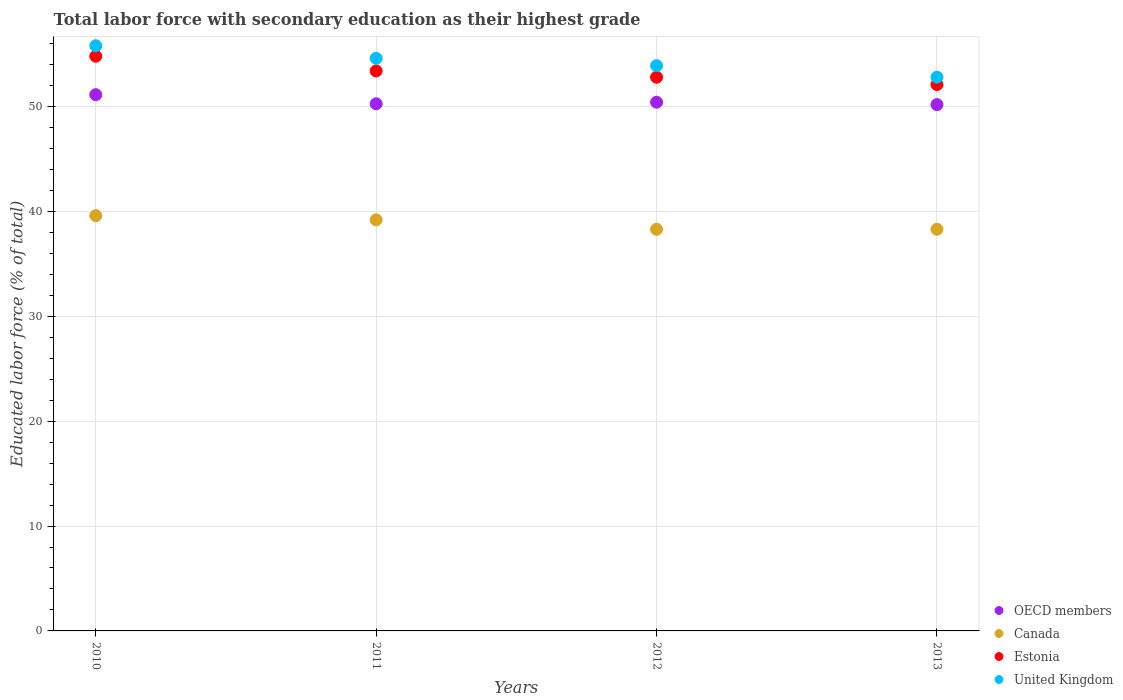Is the number of dotlines equal to the number of legend labels?
Give a very brief answer. Yes. What is the percentage of total labor force with primary education in Canada in 2010?
Offer a very short reply. 39.6. Across all years, what is the maximum percentage of total labor force with primary education in United Kingdom?
Ensure brevity in your answer.  55.8. Across all years, what is the minimum percentage of total labor force with primary education in United Kingdom?
Keep it short and to the point. 52.8. What is the total percentage of total labor force with primary education in United Kingdom in the graph?
Offer a terse response. 217.1. What is the difference between the percentage of total labor force with primary education in Canada in 2010 and that in 2013?
Offer a terse response. 1.3. What is the difference between the percentage of total labor force with primary education in OECD members in 2010 and the percentage of total labor force with primary education in Estonia in 2012?
Your response must be concise. -1.67. What is the average percentage of total labor force with primary education in OECD members per year?
Offer a very short reply. 50.5. In the year 2011, what is the difference between the percentage of total labor force with primary education in Estonia and percentage of total labor force with primary education in United Kingdom?
Your answer should be compact. -1.2. In how many years, is the percentage of total labor force with primary education in OECD members greater than 42 %?
Your answer should be very brief. 4. What is the ratio of the percentage of total labor force with primary education in Estonia in 2010 to that in 2011?
Offer a terse response. 1.03. Is the percentage of total labor force with primary education in Estonia in 2011 less than that in 2012?
Provide a short and direct response. No. What is the difference between the highest and the second highest percentage of total labor force with primary education in OECD members?
Provide a succinct answer. 0.72. What is the difference between the highest and the lowest percentage of total labor force with primary education in Estonia?
Offer a very short reply. 2.7. In how many years, is the percentage of total labor force with primary education in Estonia greater than the average percentage of total labor force with primary education in Estonia taken over all years?
Ensure brevity in your answer.  2. Is it the case that in every year, the sum of the percentage of total labor force with primary education in Estonia and percentage of total labor force with primary education in Canada  is greater than the sum of percentage of total labor force with primary education in United Kingdom and percentage of total labor force with primary education in OECD members?
Offer a very short reply. No. Is it the case that in every year, the sum of the percentage of total labor force with primary education in OECD members and percentage of total labor force with primary education in Canada  is greater than the percentage of total labor force with primary education in United Kingdom?
Offer a very short reply. Yes. Does the percentage of total labor force with primary education in United Kingdom monotonically increase over the years?
Keep it short and to the point. No. Is the percentage of total labor force with primary education in Canada strictly less than the percentage of total labor force with primary education in United Kingdom over the years?
Give a very brief answer. Yes. How many years are there in the graph?
Offer a terse response. 4. What is the difference between two consecutive major ticks on the Y-axis?
Provide a short and direct response. 10. Does the graph contain any zero values?
Give a very brief answer. No. What is the title of the graph?
Provide a short and direct response. Total labor force with secondary education as their highest grade. What is the label or title of the Y-axis?
Your answer should be compact. Educated labor force (% of total). What is the Educated labor force (% of total) in OECD members in 2010?
Offer a very short reply. 51.13. What is the Educated labor force (% of total) in Canada in 2010?
Give a very brief answer. 39.6. What is the Educated labor force (% of total) in Estonia in 2010?
Provide a succinct answer. 54.8. What is the Educated labor force (% of total) in United Kingdom in 2010?
Provide a succinct answer. 55.8. What is the Educated labor force (% of total) in OECD members in 2011?
Give a very brief answer. 50.27. What is the Educated labor force (% of total) of Canada in 2011?
Your answer should be very brief. 39.2. What is the Educated labor force (% of total) of Estonia in 2011?
Keep it short and to the point. 53.4. What is the Educated labor force (% of total) of United Kingdom in 2011?
Your answer should be compact. 54.6. What is the Educated labor force (% of total) in OECD members in 2012?
Your response must be concise. 50.41. What is the Educated labor force (% of total) of Canada in 2012?
Your response must be concise. 38.3. What is the Educated labor force (% of total) in Estonia in 2012?
Your response must be concise. 52.8. What is the Educated labor force (% of total) of United Kingdom in 2012?
Provide a succinct answer. 53.9. What is the Educated labor force (% of total) of OECD members in 2013?
Provide a succinct answer. 50.19. What is the Educated labor force (% of total) of Canada in 2013?
Provide a succinct answer. 38.3. What is the Educated labor force (% of total) in Estonia in 2013?
Provide a short and direct response. 52.1. What is the Educated labor force (% of total) in United Kingdom in 2013?
Offer a terse response. 52.8. Across all years, what is the maximum Educated labor force (% of total) in OECD members?
Provide a short and direct response. 51.13. Across all years, what is the maximum Educated labor force (% of total) of Canada?
Give a very brief answer. 39.6. Across all years, what is the maximum Educated labor force (% of total) in Estonia?
Ensure brevity in your answer.  54.8. Across all years, what is the maximum Educated labor force (% of total) of United Kingdom?
Make the answer very short. 55.8. Across all years, what is the minimum Educated labor force (% of total) of OECD members?
Make the answer very short. 50.19. Across all years, what is the minimum Educated labor force (% of total) of Canada?
Offer a terse response. 38.3. Across all years, what is the minimum Educated labor force (% of total) of Estonia?
Offer a very short reply. 52.1. Across all years, what is the minimum Educated labor force (% of total) in United Kingdom?
Provide a short and direct response. 52.8. What is the total Educated labor force (% of total) of OECD members in the graph?
Offer a very short reply. 202.01. What is the total Educated labor force (% of total) in Canada in the graph?
Make the answer very short. 155.4. What is the total Educated labor force (% of total) in Estonia in the graph?
Your answer should be very brief. 213.1. What is the total Educated labor force (% of total) in United Kingdom in the graph?
Offer a very short reply. 217.1. What is the difference between the Educated labor force (% of total) in OECD members in 2010 and that in 2011?
Provide a short and direct response. 0.87. What is the difference between the Educated labor force (% of total) in Canada in 2010 and that in 2011?
Provide a succinct answer. 0.4. What is the difference between the Educated labor force (% of total) of Estonia in 2010 and that in 2011?
Provide a short and direct response. 1.4. What is the difference between the Educated labor force (% of total) of United Kingdom in 2010 and that in 2011?
Your response must be concise. 1.2. What is the difference between the Educated labor force (% of total) in OECD members in 2010 and that in 2012?
Keep it short and to the point. 0.72. What is the difference between the Educated labor force (% of total) of Estonia in 2010 and that in 2012?
Provide a succinct answer. 2. What is the difference between the Educated labor force (% of total) of United Kingdom in 2010 and that in 2012?
Offer a very short reply. 1.9. What is the difference between the Educated labor force (% of total) in OECD members in 2010 and that in 2013?
Your answer should be compact. 0.95. What is the difference between the Educated labor force (% of total) in Canada in 2010 and that in 2013?
Offer a terse response. 1.3. What is the difference between the Educated labor force (% of total) in Estonia in 2010 and that in 2013?
Provide a succinct answer. 2.7. What is the difference between the Educated labor force (% of total) of OECD members in 2011 and that in 2012?
Ensure brevity in your answer.  -0.15. What is the difference between the Educated labor force (% of total) of Canada in 2011 and that in 2012?
Provide a short and direct response. 0.9. What is the difference between the Educated labor force (% of total) of Estonia in 2011 and that in 2012?
Give a very brief answer. 0.6. What is the difference between the Educated labor force (% of total) in United Kingdom in 2011 and that in 2012?
Provide a succinct answer. 0.7. What is the difference between the Educated labor force (% of total) of OECD members in 2011 and that in 2013?
Ensure brevity in your answer.  0.08. What is the difference between the Educated labor force (% of total) of Canada in 2011 and that in 2013?
Your answer should be very brief. 0.9. What is the difference between the Educated labor force (% of total) in OECD members in 2012 and that in 2013?
Offer a terse response. 0.23. What is the difference between the Educated labor force (% of total) in Canada in 2012 and that in 2013?
Give a very brief answer. 0. What is the difference between the Educated labor force (% of total) of OECD members in 2010 and the Educated labor force (% of total) of Canada in 2011?
Give a very brief answer. 11.93. What is the difference between the Educated labor force (% of total) in OECD members in 2010 and the Educated labor force (% of total) in Estonia in 2011?
Make the answer very short. -2.27. What is the difference between the Educated labor force (% of total) in OECD members in 2010 and the Educated labor force (% of total) in United Kingdom in 2011?
Your answer should be compact. -3.47. What is the difference between the Educated labor force (% of total) of Canada in 2010 and the Educated labor force (% of total) of Estonia in 2011?
Offer a terse response. -13.8. What is the difference between the Educated labor force (% of total) of Canada in 2010 and the Educated labor force (% of total) of United Kingdom in 2011?
Keep it short and to the point. -15. What is the difference between the Educated labor force (% of total) in OECD members in 2010 and the Educated labor force (% of total) in Canada in 2012?
Provide a succinct answer. 12.83. What is the difference between the Educated labor force (% of total) of OECD members in 2010 and the Educated labor force (% of total) of Estonia in 2012?
Make the answer very short. -1.67. What is the difference between the Educated labor force (% of total) of OECD members in 2010 and the Educated labor force (% of total) of United Kingdom in 2012?
Your answer should be very brief. -2.77. What is the difference between the Educated labor force (% of total) in Canada in 2010 and the Educated labor force (% of total) in Estonia in 2012?
Provide a short and direct response. -13.2. What is the difference between the Educated labor force (% of total) in Canada in 2010 and the Educated labor force (% of total) in United Kingdom in 2012?
Provide a short and direct response. -14.3. What is the difference between the Educated labor force (% of total) of OECD members in 2010 and the Educated labor force (% of total) of Canada in 2013?
Offer a very short reply. 12.83. What is the difference between the Educated labor force (% of total) of OECD members in 2010 and the Educated labor force (% of total) of Estonia in 2013?
Provide a short and direct response. -0.97. What is the difference between the Educated labor force (% of total) of OECD members in 2010 and the Educated labor force (% of total) of United Kingdom in 2013?
Your answer should be very brief. -1.67. What is the difference between the Educated labor force (% of total) of Canada in 2010 and the Educated labor force (% of total) of Estonia in 2013?
Provide a short and direct response. -12.5. What is the difference between the Educated labor force (% of total) of Canada in 2010 and the Educated labor force (% of total) of United Kingdom in 2013?
Provide a short and direct response. -13.2. What is the difference between the Educated labor force (% of total) in Estonia in 2010 and the Educated labor force (% of total) in United Kingdom in 2013?
Make the answer very short. 2. What is the difference between the Educated labor force (% of total) of OECD members in 2011 and the Educated labor force (% of total) of Canada in 2012?
Give a very brief answer. 11.97. What is the difference between the Educated labor force (% of total) of OECD members in 2011 and the Educated labor force (% of total) of Estonia in 2012?
Keep it short and to the point. -2.53. What is the difference between the Educated labor force (% of total) of OECD members in 2011 and the Educated labor force (% of total) of United Kingdom in 2012?
Provide a succinct answer. -3.63. What is the difference between the Educated labor force (% of total) of Canada in 2011 and the Educated labor force (% of total) of United Kingdom in 2012?
Ensure brevity in your answer.  -14.7. What is the difference between the Educated labor force (% of total) of OECD members in 2011 and the Educated labor force (% of total) of Canada in 2013?
Offer a terse response. 11.97. What is the difference between the Educated labor force (% of total) in OECD members in 2011 and the Educated labor force (% of total) in Estonia in 2013?
Your answer should be very brief. -1.83. What is the difference between the Educated labor force (% of total) in OECD members in 2011 and the Educated labor force (% of total) in United Kingdom in 2013?
Provide a succinct answer. -2.53. What is the difference between the Educated labor force (% of total) of Canada in 2011 and the Educated labor force (% of total) of Estonia in 2013?
Offer a very short reply. -12.9. What is the difference between the Educated labor force (% of total) of OECD members in 2012 and the Educated labor force (% of total) of Canada in 2013?
Give a very brief answer. 12.11. What is the difference between the Educated labor force (% of total) in OECD members in 2012 and the Educated labor force (% of total) in Estonia in 2013?
Your answer should be compact. -1.69. What is the difference between the Educated labor force (% of total) of OECD members in 2012 and the Educated labor force (% of total) of United Kingdom in 2013?
Give a very brief answer. -2.39. What is the difference between the Educated labor force (% of total) of Canada in 2012 and the Educated labor force (% of total) of Estonia in 2013?
Make the answer very short. -13.8. What is the difference between the Educated labor force (% of total) in Canada in 2012 and the Educated labor force (% of total) in United Kingdom in 2013?
Your answer should be very brief. -14.5. What is the average Educated labor force (% of total) of OECD members per year?
Ensure brevity in your answer.  50.5. What is the average Educated labor force (% of total) in Canada per year?
Your response must be concise. 38.85. What is the average Educated labor force (% of total) in Estonia per year?
Ensure brevity in your answer.  53.27. What is the average Educated labor force (% of total) in United Kingdom per year?
Make the answer very short. 54.27. In the year 2010, what is the difference between the Educated labor force (% of total) in OECD members and Educated labor force (% of total) in Canada?
Offer a very short reply. 11.53. In the year 2010, what is the difference between the Educated labor force (% of total) in OECD members and Educated labor force (% of total) in Estonia?
Your answer should be compact. -3.67. In the year 2010, what is the difference between the Educated labor force (% of total) of OECD members and Educated labor force (% of total) of United Kingdom?
Your answer should be compact. -4.67. In the year 2010, what is the difference between the Educated labor force (% of total) in Canada and Educated labor force (% of total) in Estonia?
Ensure brevity in your answer.  -15.2. In the year 2010, what is the difference between the Educated labor force (% of total) of Canada and Educated labor force (% of total) of United Kingdom?
Your answer should be compact. -16.2. In the year 2010, what is the difference between the Educated labor force (% of total) of Estonia and Educated labor force (% of total) of United Kingdom?
Your response must be concise. -1. In the year 2011, what is the difference between the Educated labor force (% of total) of OECD members and Educated labor force (% of total) of Canada?
Provide a succinct answer. 11.07. In the year 2011, what is the difference between the Educated labor force (% of total) of OECD members and Educated labor force (% of total) of Estonia?
Your response must be concise. -3.13. In the year 2011, what is the difference between the Educated labor force (% of total) in OECD members and Educated labor force (% of total) in United Kingdom?
Make the answer very short. -4.33. In the year 2011, what is the difference between the Educated labor force (% of total) of Canada and Educated labor force (% of total) of Estonia?
Offer a very short reply. -14.2. In the year 2011, what is the difference between the Educated labor force (% of total) of Canada and Educated labor force (% of total) of United Kingdom?
Make the answer very short. -15.4. In the year 2012, what is the difference between the Educated labor force (% of total) in OECD members and Educated labor force (% of total) in Canada?
Give a very brief answer. 12.11. In the year 2012, what is the difference between the Educated labor force (% of total) in OECD members and Educated labor force (% of total) in Estonia?
Your answer should be compact. -2.39. In the year 2012, what is the difference between the Educated labor force (% of total) in OECD members and Educated labor force (% of total) in United Kingdom?
Ensure brevity in your answer.  -3.49. In the year 2012, what is the difference between the Educated labor force (% of total) in Canada and Educated labor force (% of total) in Estonia?
Your answer should be compact. -14.5. In the year 2012, what is the difference between the Educated labor force (% of total) in Canada and Educated labor force (% of total) in United Kingdom?
Your response must be concise. -15.6. In the year 2013, what is the difference between the Educated labor force (% of total) in OECD members and Educated labor force (% of total) in Canada?
Ensure brevity in your answer.  11.89. In the year 2013, what is the difference between the Educated labor force (% of total) in OECD members and Educated labor force (% of total) in Estonia?
Your answer should be very brief. -1.91. In the year 2013, what is the difference between the Educated labor force (% of total) of OECD members and Educated labor force (% of total) of United Kingdom?
Keep it short and to the point. -2.61. In the year 2013, what is the difference between the Educated labor force (% of total) in Canada and Educated labor force (% of total) in Estonia?
Provide a succinct answer. -13.8. What is the ratio of the Educated labor force (% of total) in OECD members in 2010 to that in 2011?
Provide a succinct answer. 1.02. What is the ratio of the Educated labor force (% of total) of Canada in 2010 to that in 2011?
Provide a short and direct response. 1.01. What is the ratio of the Educated labor force (% of total) of Estonia in 2010 to that in 2011?
Your response must be concise. 1.03. What is the ratio of the Educated labor force (% of total) in OECD members in 2010 to that in 2012?
Your answer should be very brief. 1.01. What is the ratio of the Educated labor force (% of total) of Canada in 2010 to that in 2012?
Your answer should be compact. 1.03. What is the ratio of the Educated labor force (% of total) in Estonia in 2010 to that in 2012?
Your answer should be compact. 1.04. What is the ratio of the Educated labor force (% of total) in United Kingdom in 2010 to that in 2012?
Ensure brevity in your answer.  1.04. What is the ratio of the Educated labor force (% of total) of OECD members in 2010 to that in 2013?
Make the answer very short. 1.02. What is the ratio of the Educated labor force (% of total) of Canada in 2010 to that in 2013?
Your answer should be very brief. 1.03. What is the ratio of the Educated labor force (% of total) of Estonia in 2010 to that in 2013?
Ensure brevity in your answer.  1.05. What is the ratio of the Educated labor force (% of total) of United Kingdom in 2010 to that in 2013?
Make the answer very short. 1.06. What is the ratio of the Educated labor force (% of total) in Canada in 2011 to that in 2012?
Provide a short and direct response. 1.02. What is the ratio of the Educated labor force (% of total) of Estonia in 2011 to that in 2012?
Your response must be concise. 1.01. What is the ratio of the Educated labor force (% of total) in OECD members in 2011 to that in 2013?
Ensure brevity in your answer.  1. What is the ratio of the Educated labor force (% of total) in Canada in 2011 to that in 2013?
Offer a very short reply. 1.02. What is the ratio of the Educated labor force (% of total) of Estonia in 2011 to that in 2013?
Provide a short and direct response. 1.02. What is the ratio of the Educated labor force (% of total) of United Kingdom in 2011 to that in 2013?
Give a very brief answer. 1.03. What is the ratio of the Educated labor force (% of total) in Estonia in 2012 to that in 2013?
Provide a short and direct response. 1.01. What is the ratio of the Educated labor force (% of total) of United Kingdom in 2012 to that in 2013?
Make the answer very short. 1.02. What is the difference between the highest and the second highest Educated labor force (% of total) of OECD members?
Ensure brevity in your answer.  0.72. What is the difference between the highest and the lowest Educated labor force (% of total) in OECD members?
Provide a short and direct response. 0.95. What is the difference between the highest and the lowest Educated labor force (% of total) in Estonia?
Give a very brief answer. 2.7. What is the difference between the highest and the lowest Educated labor force (% of total) in United Kingdom?
Your response must be concise. 3. 